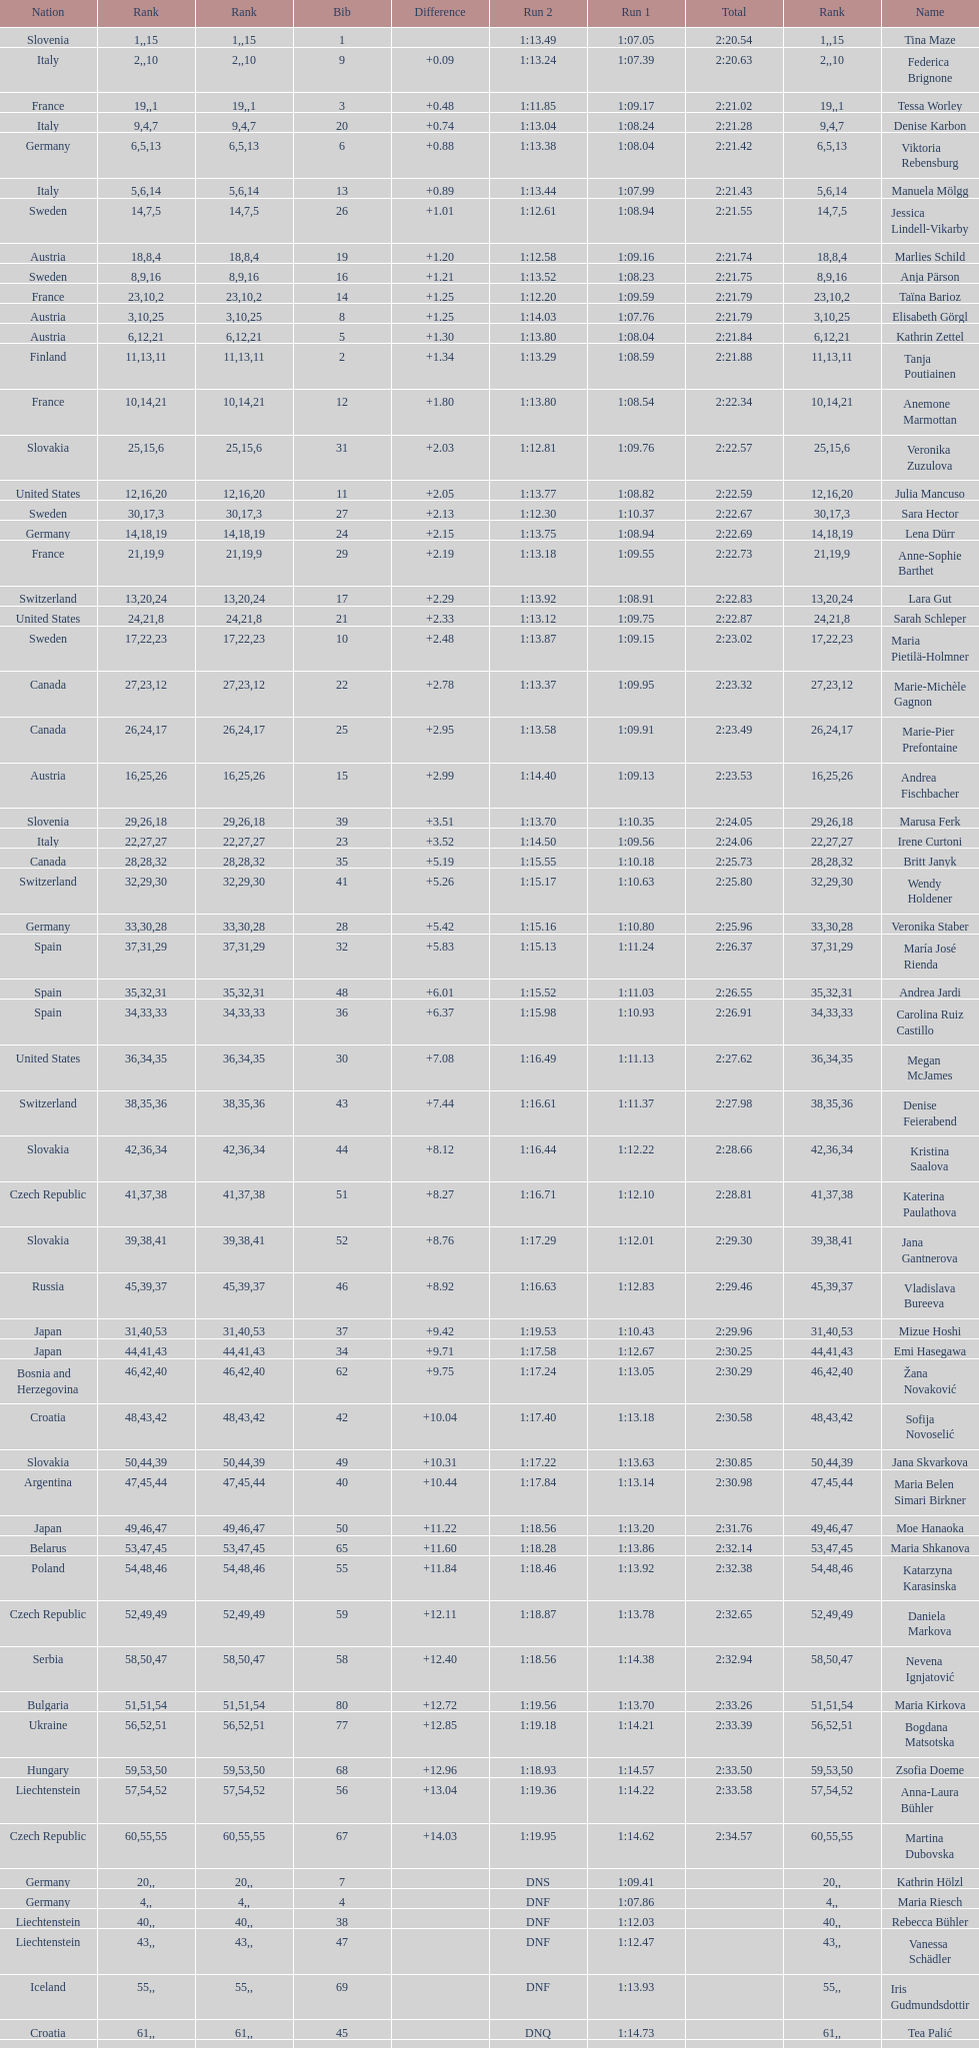How many total names are there? 116. 